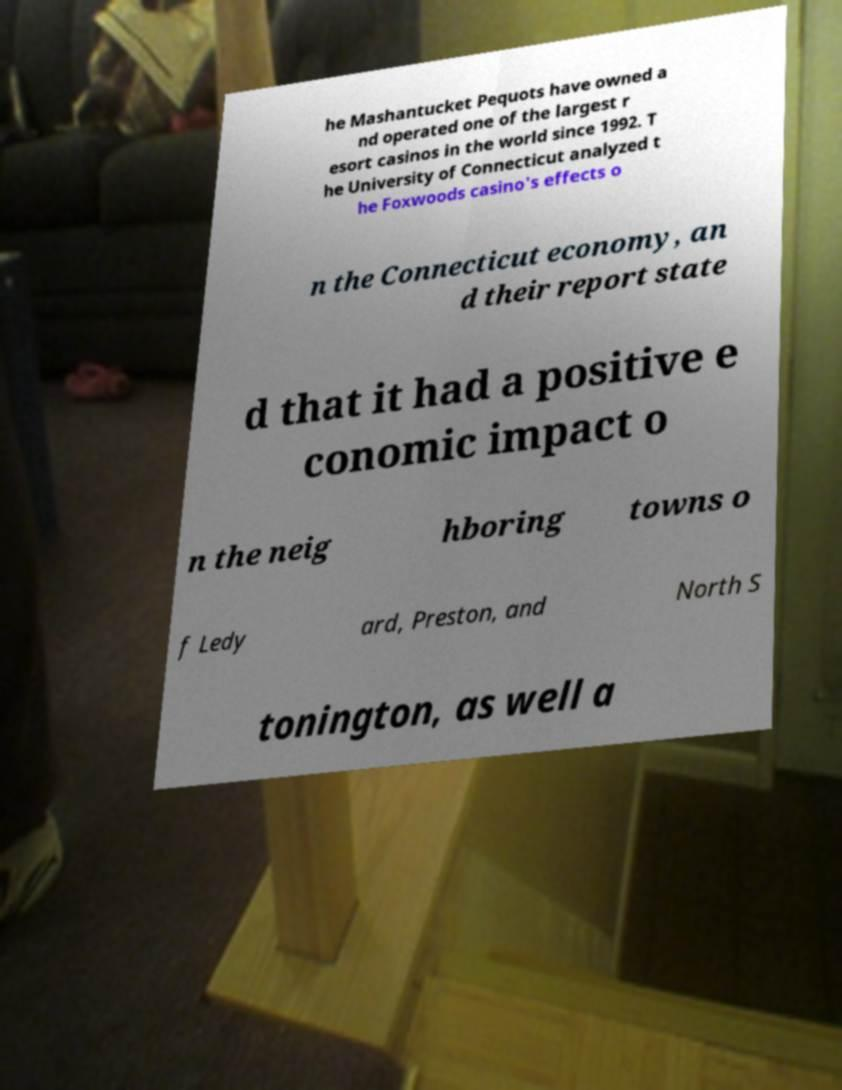Please read and relay the text visible in this image. What does it say? he Mashantucket Pequots have owned a nd operated one of the largest r esort casinos in the world since 1992. T he University of Connecticut analyzed t he Foxwoods casino's effects o n the Connecticut economy, an d their report state d that it had a positive e conomic impact o n the neig hboring towns o f Ledy ard, Preston, and North S tonington, as well a 